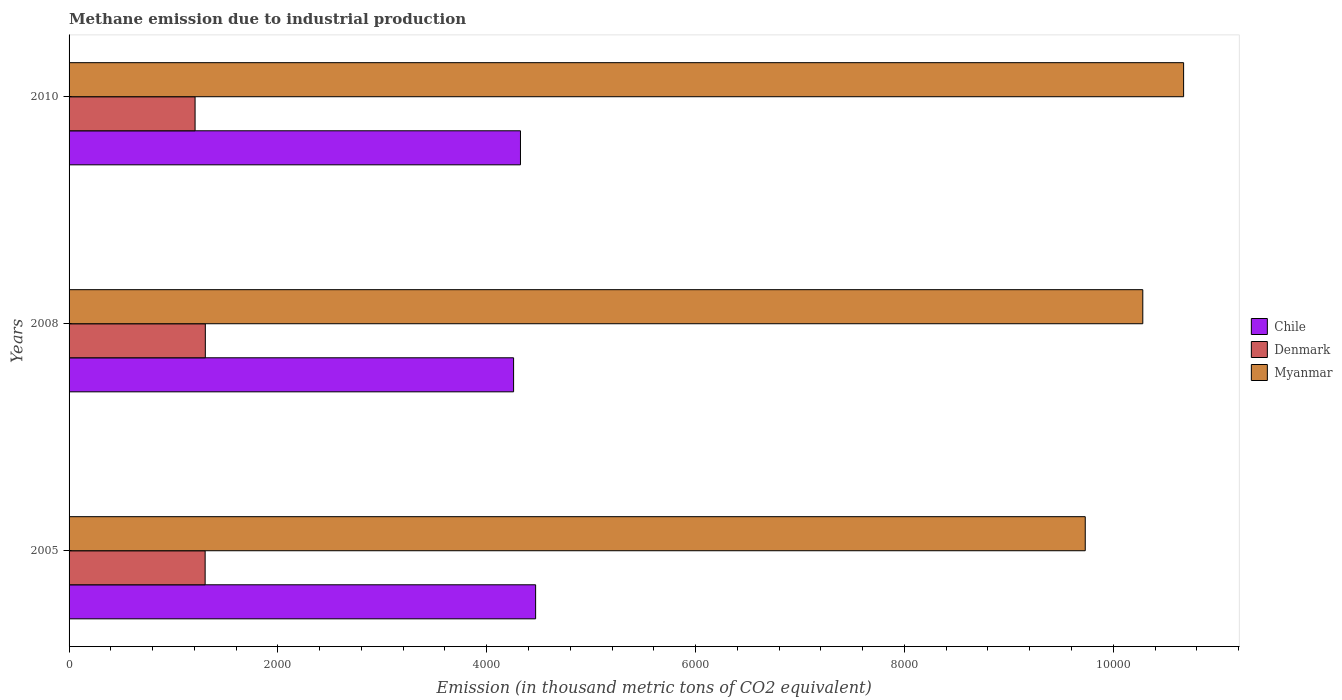How many different coloured bars are there?
Provide a short and direct response. 3. How many groups of bars are there?
Ensure brevity in your answer.  3. How many bars are there on the 3rd tick from the top?
Your answer should be very brief. 3. What is the amount of methane emitted in Myanmar in 2010?
Make the answer very short. 1.07e+04. Across all years, what is the maximum amount of methane emitted in Chile?
Provide a short and direct response. 4468. Across all years, what is the minimum amount of methane emitted in Denmark?
Give a very brief answer. 1206.8. In which year was the amount of methane emitted in Myanmar maximum?
Your answer should be compact. 2010. What is the total amount of methane emitted in Denmark in the graph?
Offer a terse response. 3814.8. What is the difference between the amount of methane emitted in Denmark in 2008 and that in 2010?
Your answer should be compact. 98.1. What is the difference between the amount of methane emitted in Myanmar in 2005 and the amount of methane emitted in Chile in 2008?
Provide a short and direct response. 5474.7. What is the average amount of methane emitted in Myanmar per year?
Offer a terse response. 1.02e+04. In the year 2005, what is the difference between the amount of methane emitted in Chile and amount of methane emitted in Myanmar?
Keep it short and to the point. -5263.7. In how many years, is the amount of methane emitted in Myanmar greater than 9200 thousand metric tons?
Your answer should be very brief. 3. What is the ratio of the amount of methane emitted in Myanmar in 2005 to that in 2008?
Your response must be concise. 0.95. Is the amount of methane emitted in Denmark in 2008 less than that in 2010?
Your answer should be very brief. No. What is the difference between the highest and the second highest amount of methane emitted in Chile?
Offer a very short reply. 145.1. What is the difference between the highest and the lowest amount of methane emitted in Chile?
Give a very brief answer. 211. What does the 1st bar from the top in 2008 represents?
Your answer should be compact. Myanmar. Are all the bars in the graph horizontal?
Provide a succinct answer. Yes. What is the difference between two consecutive major ticks on the X-axis?
Offer a terse response. 2000. Are the values on the major ticks of X-axis written in scientific E-notation?
Make the answer very short. No. Does the graph contain any zero values?
Your answer should be compact. No. What is the title of the graph?
Ensure brevity in your answer.  Methane emission due to industrial production. What is the label or title of the X-axis?
Your response must be concise. Emission (in thousand metric tons of CO2 equivalent). What is the Emission (in thousand metric tons of CO2 equivalent) of Chile in 2005?
Your response must be concise. 4468. What is the Emission (in thousand metric tons of CO2 equivalent) in Denmark in 2005?
Ensure brevity in your answer.  1303.1. What is the Emission (in thousand metric tons of CO2 equivalent) of Myanmar in 2005?
Give a very brief answer. 9731.7. What is the Emission (in thousand metric tons of CO2 equivalent) in Chile in 2008?
Your answer should be compact. 4257. What is the Emission (in thousand metric tons of CO2 equivalent) in Denmark in 2008?
Ensure brevity in your answer.  1304.9. What is the Emission (in thousand metric tons of CO2 equivalent) in Myanmar in 2008?
Keep it short and to the point. 1.03e+04. What is the Emission (in thousand metric tons of CO2 equivalent) in Chile in 2010?
Keep it short and to the point. 4322.9. What is the Emission (in thousand metric tons of CO2 equivalent) of Denmark in 2010?
Provide a succinct answer. 1206.8. What is the Emission (in thousand metric tons of CO2 equivalent) of Myanmar in 2010?
Offer a very short reply. 1.07e+04. Across all years, what is the maximum Emission (in thousand metric tons of CO2 equivalent) in Chile?
Offer a very short reply. 4468. Across all years, what is the maximum Emission (in thousand metric tons of CO2 equivalent) in Denmark?
Your answer should be very brief. 1304.9. Across all years, what is the maximum Emission (in thousand metric tons of CO2 equivalent) in Myanmar?
Offer a terse response. 1.07e+04. Across all years, what is the minimum Emission (in thousand metric tons of CO2 equivalent) in Chile?
Offer a terse response. 4257. Across all years, what is the minimum Emission (in thousand metric tons of CO2 equivalent) of Denmark?
Your response must be concise. 1206.8. Across all years, what is the minimum Emission (in thousand metric tons of CO2 equivalent) in Myanmar?
Your response must be concise. 9731.7. What is the total Emission (in thousand metric tons of CO2 equivalent) in Chile in the graph?
Provide a succinct answer. 1.30e+04. What is the total Emission (in thousand metric tons of CO2 equivalent) of Denmark in the graph?
Provide a succinct answer. 3814.8. What is the total Emission (in thousand metric tons of CO2 equivalent) in Myanmar in the graph?
Offer a very short reply. 3.07e+04. What is the difference between the Emission (in thousand metric tons of CO2 equivalent) in Chile in 2005 and that in 2008?
Provide a succinct answer. 211. What is the difference between the Emission (in thousand metric tons of CO2 equivalent) in Denmark in 2005 and that in 2008?
Make the answer very short. -1.8. What is the difference between the Emission (in thousand metric tons of CO2 equivalent) in Myanmar in 2005 and that in 2008?
Your response must be concise. -551. What is the difference between the Emission (in thousand metric tons of CO2 equivalent) of Chile in 2005 and that in 2010?
Make the answer very short. 145.1. What is the difference between the Emission (in thousand metric tons of CO2 equivalent) of Denmark in 2005 and that in 2010?
Give a very brief answer. 96.3. What is the difference between the Emission (in thousand metric tons of CO2 equivalent) in Myanmar in 2005 and that in 2010?
Provide a short and direct response. -941.9. What is the difference between the Emission (in thousand metric tons of CO2 equivalent) of Chile in 2008 and that in 2010?
Ensure brevity in your answer.  -65.9. What is the difference between the Emission (in thousand metric tons of CO2 equivalent) in Denmark in 2008 and that in 2010?
Give a very brief answer. 98.1. What is the difference between the Emission (in thousand metric tons of CO2 equivalent) of Myanmar in 2008 and that in 2010?
Offer a very short reply. -390.9. What is the difference between the Emission (in thousand metric tons of CO2 equivalent) in Chile in 2005 and the Emission (in thousand metric tons of CO2 equivalent) in Denmark in 2008?
Your answer should be very brief. 3163.1. What is the difference between the Emission (in thousand metric tons of CO2 equivalent) in Chile in 2005 and the Emission (in thousand metric tons of CO2 equivalent) in Myanmar in 2008?
Offer a very short reply. -5814.7. What is the difference between the Emission (in thousand metric tons of CO2 equivalent) in Denmark in 2005 and the Emission (in thousand metric tons of CO2 equivalent) in Myanmar in 2008?
Offer a very short reply. -8979.6. What is the difference between the Emission (in thousand metric tons of CO2 equivalent) of Chile in 2005 and the Emission (in thousand metric tons of CO2 equivalent) of Denmark in 2010?
Your answer should be compact. 3261.2. What is the difference between the Emission (in thousand metric tons of CO2 equivalent) in Chile in 2005 and the Emission (in thousand metric tons of CO2 equivalent) in Myanmar in 2010?
Make the answer very short. -6205.6. What is the difference between the Emission (in thousand metric tons of CO2 equivalent) in Denmark in 2005 and the Emission (in thousand metric tons of CO2 equivalent) in Myanmar in 2010?
Your answer should be very brief. -9370.5. What is the difference between the Emission (in thousand metric tons of CO2 equivalent) in Chile in 2008 and the Emission (in thousand metric tons of CO2 equivalent) in Denmark in 2010?
Offer a terse response. 3050.2. What is the difference between the Emission (in thousand metric tons of CO2 equivalent) of Chile in 2008 and the Emission (in thousand metric tons of CO2 equivalent) of Myanmar in 2010?
Your response must be concise. -6416.6. What is the difference between the Emission (in thousand metric tons of CO2 equivalent) of Denmark in 2008 and the Emission (in thousand metric tons of CO2 equivalent) of Myanmar in 2010?
Your response must be concise. -9368.7. What is the average Emission (in thousand metric tons of CO2 equivalent) of Chile per year?
Make the answer very short. 4349.3. What is the average Emission (in thousand metric tons of CO2 equivalent) in Denmark per year?
Provide a succinct answer. 1271.6. What is the average Emission (in thousand metric tons of CO2 equivalent) of Myanmar per year?
Your answer should be compact. 1.02e+04. In the year 2005, what is the difference between the Emission (in thousand metric tons of CO2 equivalent) of Chile and Emission (in thousand metric tons of CO2 equivalent) of Denmark?
Provide a succinct answer. 3164.9. In the year 2005, what is the difference between the Emission (in thousand metric tons of CO2 equivalent) of Chile and Emission (in thousand metric tons of CO2 equivalent) of Myanmar?
Offer a very short reply. -5263.7. In the year 2005, what is the difference between the Emission (in thousand metric tons of CO2 equivalent) of Denmark and Emission (in thousand metric tons of CO2 equivalent) of Myanmar?
Your answer should be compact. -8428.6. In the year 2008, what is the difference between the Emission (in thousand metric tons of CO2 equivalent) in Chile and Emission (in thousand metric tons of CO2 equivalent) in Denmark?
Offer a terse response. 2952.1. In the year 2008, what is the difference between the Emission (in thousand metric tons of CO2 equivalent) in Chile and Emission (in thousand metric tons of CO2 equivalent) in Myanmar?
Your response must be concise. -6025.7. In the year 2008, what is the difference between the Emission (in thousand metric tons of CO2 equivalent) of Denmark and Emission (in thousand metric tons of CO2 equivalent) of Myanmar?
Offer a terse response. -8977.8. In the year 2010, what is the difference between the Emission (in thousand metric tons of CO2 equivalent) of Chile and Emission (in thousand metric tons of CO2 equivalent) of Denmark?
Provide a short and direct response. 3116.1. In the year 2010, what is the difference between the Emission (in thousand metric tons of CO2 equivalent) of Chile and Emission (in thousand metric tons of CO2 equivalent) of Myanmar?
Offer a terse response. -6350.7. In the year 2010, what is the difference between the Emission (in thousand metric tons of CO2 equivalent) in Denmark and Emission (in thousand metric tons of CO2 equivalent) in Myanmar?
Offer a terse response. -9466.8. What is the ratio of the Emission (in thousand metric tons of CO2 equivalent) of Chile in 2005 to that in 2008?
Offer a very short reply. 1.05. What is the ratio of the Emission (in thousand metric tons of CO2 equivalent) in Myanmar in 2005 to that in 2008?
Keep it short and to the point. 0.95. What is the ratio of the Emission (in thousand metric tons of CO2 equivalent) in Chile in 2005 to that in 2010?
Offer a terse response. 1.03. What is the ratio of the Emission (in thousand metric tons of CO2 equivalent) of Denmark in 2005 to that in 2010?
Your answer should be very brief. 1.08. What is the ratio of the Emission (in thousand metric tons of CO2 equivalent) in Myanmar in 2005 to that in 2010?
Ensure brevity in your answer.  0.91. What is the ratio of the Emission (in thousand metric tons of CO2 equivalent) in Denmark in 2008 to that in 2010?
Your response must be concise. 1.08. What is the ratio of the Emission (in thousand metric tons of CO2 equivalent) in Myanmar in 2008 to that in 2010?
Offer a very short reply. 0.96. What is the difference between the highest and the second highest Emission (in thousand metric tons of CO2 equivalent) in Chile?
Your response must be concise. 145.1. What is the difference between the highest and the second highest Emission (in thousand metric tons of CO2 equivalent) in Myanmar?
Provide a short and direct response. 390.9. What is the difference between the highest and the lowest Emission (in thousand metric tons of CO2 equivalent) in Chile?
Provide a short and direct response. 211. What is the difference between the highest and the lowest Emission (in thousand metric tons of CO2 equivalent) in Denmark?
Make the answer very short. 98.1. What is the difference between the highest and the lowest Emission (in thousand metric tons of CO2 equivalent) in Myanmar?
Provide a succinct answer. 941.9. 